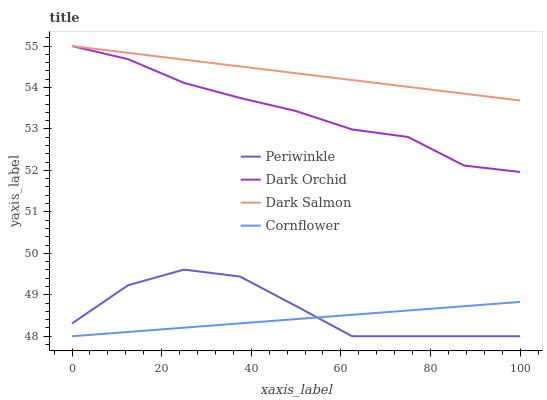Does Cornflower have the minimum area under the curve?
Answer yes or no. Yes. Does Dark Salmon have the maximum area under the curve?
Answer yes or no. Yes. Does Periwinkle have the minimum area under the curve?
Answer yes or no. No. Does Periwinkle have the maximum area under the curve?
Answer yes or no. No. Is Dark Salmon the smoothest?
Answer yes or no. Yes. Is Periwinkle the roughest?
Answer yes or no. Yes. Is Periwinkle the smoothest?
Answer yes or no. No. Is Dark Salmon the roughest?
Answer yes or no. No. Does Dark Salmon have the lowest value?
Answer yes or no. No. Does Dark Orchid have the highest value?
Answer yes or no. Yes. Does Periwinkle have the highest value?
Answer yes or no. No. Is Cornflower less than Dark Salmon?
Answer yes or no. Yes. Is Dark Salmon greater than Cornflower?
Answer yes or no. Yes. Does Cornflower intersect Periwinkle?
Answer yes or no. Yes. Is Cornflower less than Periwinkle?
Answer yes or no. No. Is Cornflower greater than Periwinkle?
Answer yes or no. No. Does Cornflower intersect Dark Salmon?
Answer yes or no. No. 